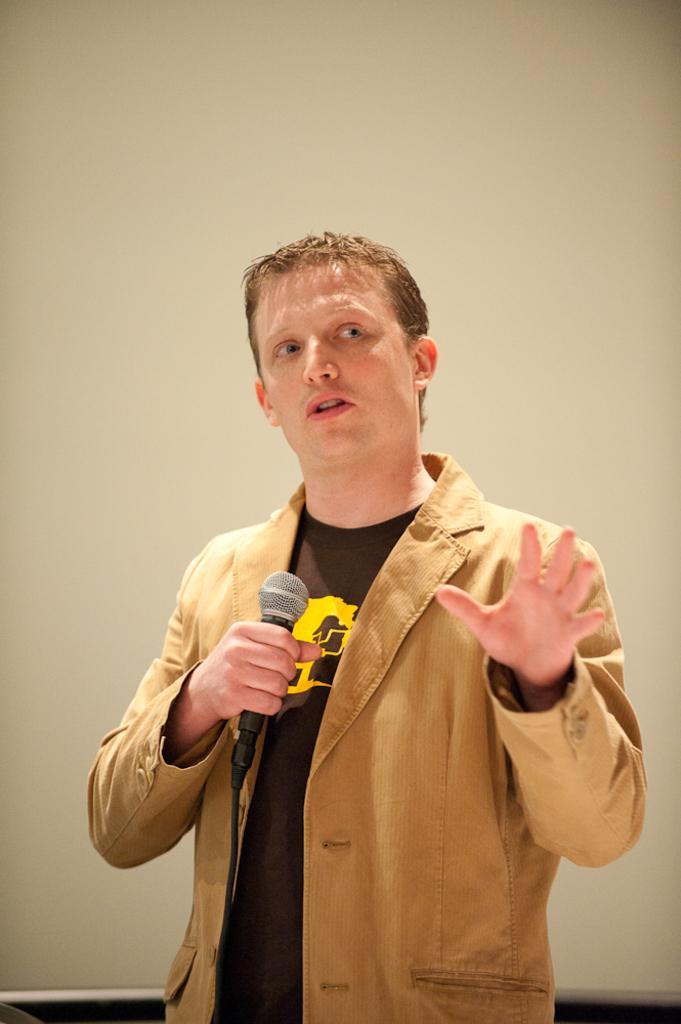Can you describe this image briefly? In this image there is a man holding a mike in his hand, in the background there is a wall. 